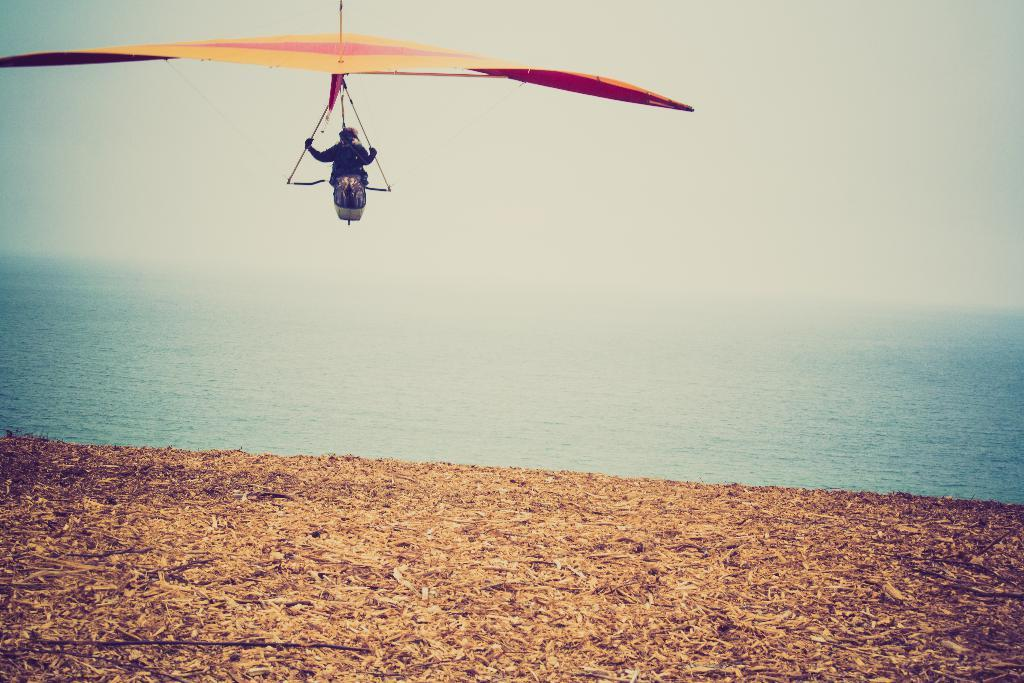What is the person in the image doing? The person is sitting on an object in the image. What can be seen in the background of the image? The sky, water, and ground are visible in the background of the image. Can you describe the natural environment in the image? The image features a natural environment with water and sky visible in the background. What type of knife is being used in the process depicted in the image? There is no knife or process present in the image; it features a person sitting on an object in a natural environment. 